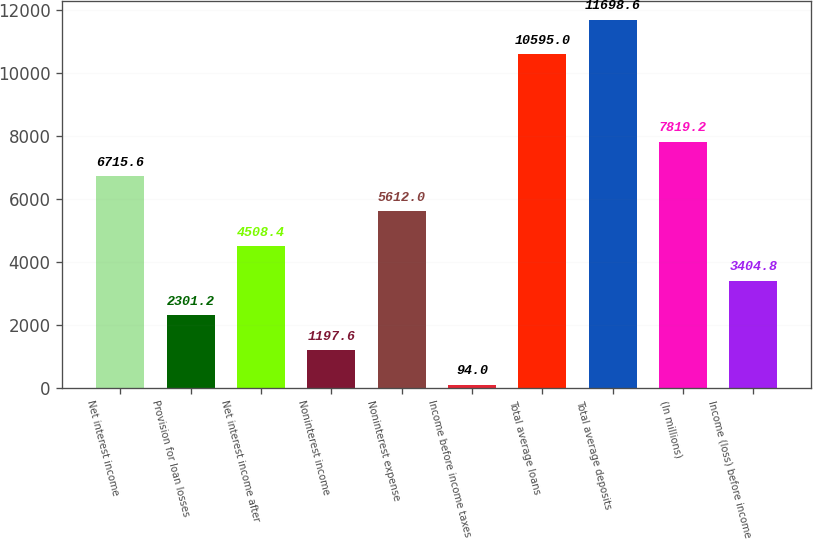Convert chart to OTSL. <chart><loc_0><loc_0><loc_500><loc_500><bar_chart><fcel>Net interest income<fcel>Provision for loan losses<fcel>Net interest income after<fcel>Noninterest income<fcel>Noninterest expense<fcel>Income before income taxes<fcel>Total average loans<fcel>Total average deposits<fcel>(In millions)<fcel>Income (loss) before income<nl><fcel>6715.6<fcel>2301.2<fcel>4508.4<fcel>1197.6<fcel>5612<fcel>94<fcel>10595<fcel>11698.6<fcel>7819.2<fcel>3404.8<nl></chart> 